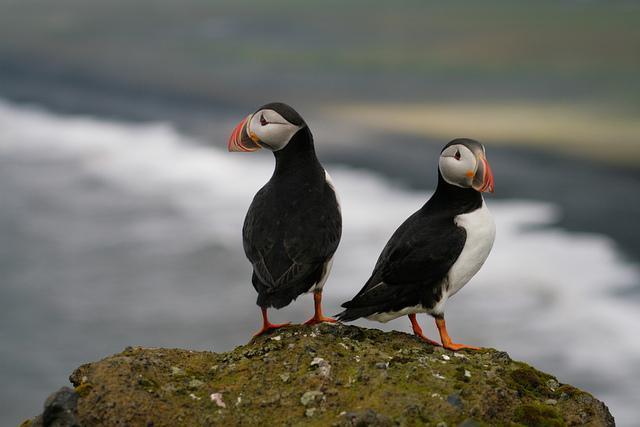How many birds can you see?
Give a very brief answer. 2. How many cups are by the sink?
Give a very brief answer. 0. 